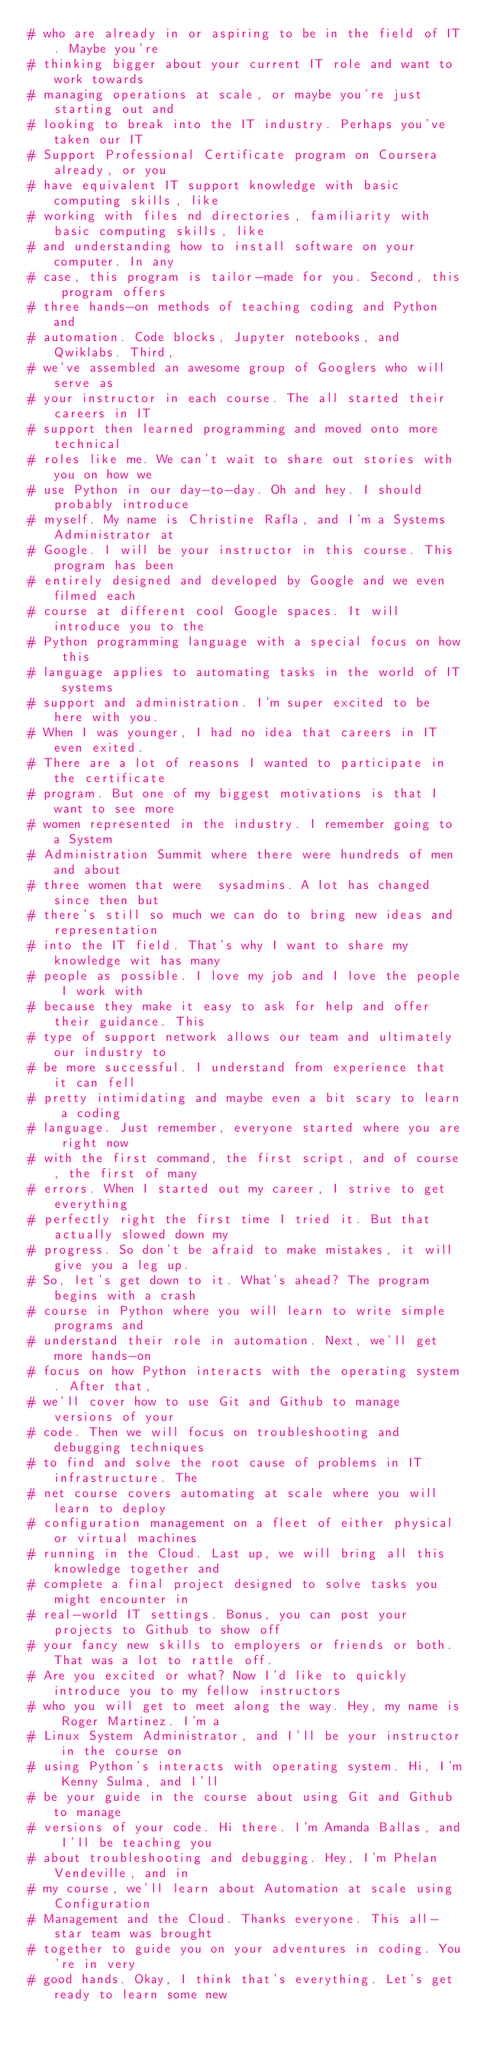Convert code to text. <code><loc_0><loc_0><loc_500><loc_500><_Python_># who are already in or aspiring to be in the field of IT. Maybe you're
# thinking bigger about your current IT role and want to work towards
# managing operations at scale, or maybe you're just starting out and
# looking to break into the IT industry. Perhaps you've taken our IT
# Support Professional Certificate program on Coursera already, or you
# have equivalent IT support knowledge with basic computing skills, like
# working with files nd directories, familiarity with basic computing skills, like
# and understanding how to install software on your computer. In any
# case, this program is tailor-made for you. Second, this program offers
# three hands-on methods of teaching coding and Python and
# automation. Code blocks, Jupyter notebooks, and Qwiklabs. Third,
# we've assembled an awesome group of Googlers who will serve as
# your instructor in each course. The all started their careers in IT
# support then learned programming and moved onto more technical
# roles like me. We can't wait to share out stories with you on how we
# use Python in our day-to-day. Oh and hey. I should probably introduce
# myself. My name is Christine Rafla, and I'm a Systems Administrator at
# Google. I will be your instructor in this course. This program has been
# entirely designed and developed by Google and we even filmed each
# course at different cool Google spaces. It will introduce you to the
# Python programming language with a special focus on how this
# language applies to automating tasks in the world of IT systems
# support and administration. I'm super excited to be here with you.
# When I was younger, I had no idea that careers in IT even exited.
# There are a lot of reasons I wanted to participate in the certificate
# program. But one of my biggest motivations is that I want to see more
# women represented in the industry. I remember going to a System
# Administration Summit where there were hundreds of men and about
# three women that were  sysadmins. A lot has changed since then but
# there's still so much we can do to bring new ideas and representation
# into the IT field. That's why I want to share my knowledge wit has many
# people as possible. I love my job and I love the people I work with
# because they make it easy to ask for help and offer their guidance. This
# type of support network allows our team and ultimately our industry to
# be more successful. I understand from experience that it can fell
# pretty intimidating and maybe even a bit scary to learn a coding
# language. Just remember, everyone started where you are right now
# with the first command, the first script, and of course, the first of many
# errors. When I started out my career, I strive to get everything
# perfectly right the first time I tried it. But that actually slowed down my
# progress. So don't be afraid to make mistakes, it will give you a leg up.
# So, let's get down to it. What's ahead? The program begins with a crash
# course in Python where you will learn to write simple programs and
# understand their role in automation. Next, we'll get more hands-on
# focus on how Python interacts with the operating system. After that,
# we'll cover how to use Git and Github to manage versions of your
# code. Then we will focus on troubleshooting and debugging techniques
# to find and solve the root cause of problems in IT infrastructure. The
# net course covers automating at scale where you will learn to deploy
# configuration management on a fleet of either physical or virtual machines
# running in the Cloud. Last up, we will bring all this knowledge together and
# complete a final project designed to solve tasks you might encounter in
# real-world IT settings. Bonus, you can post your projects to Github to show off
# your fancy new skills to employers or friends or both. That was a lot to rattle off.
# Are you excited or what? Now I'd like to quickly introduce you to my fellow instructors
# who you will get to meet along the way. Hey, my name is Roger Martinez. I'm a
# Linux System Administrator, and I'll be your instructor in the course on
# using Python's interacts with operating system. Hi, I'm Kenny Sulma, and I'll
# be your guide in the course about using Git and Github to manage
# versions of your code. Hi there. I'm Amanda Ballas, and I'll be teaching you
# about troubleshooting and debugging. Hey, I'm Phelan Vendeville, and in
# my course, we'll learn about Automation at scale using Configuration
# Management and the Cloud. Thanks everyone. This all-star team was brought
# together to guide you on your adventures in coding. You're in very
# good hands. Okay, I think that's everything. Let's get ready to learn some new</code> 